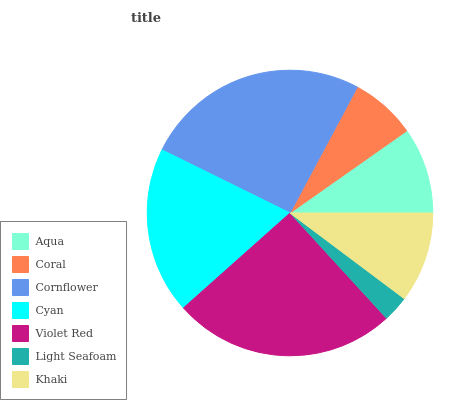Is Light Seafoam the minimum?
Answer yes or no. Yes. Is Cornflower the maximum?
Answer yes or no. Yes. Is Coral the minimum?
Answer yes or no. No. Is Coral the maximum?
Answer yes or no. No. Is Aqua greater than Coral?
Answer yes or no. Yes. Is Coral less than Aqua?
Answer yes or no. Yes. Is Coral greater than Aqua?
Answer yes or no. No. Is Aqua less than Coral?
Answer yes or no. No. Is Khaki the high median?
Answer yes or no. Yes. Is Khaki the low median?
Answer yes or no. Yes. Is Light Seafoam the high median?
Answer yes or no. No. Is Cornflower the low median?
Answer yes or no. No. 